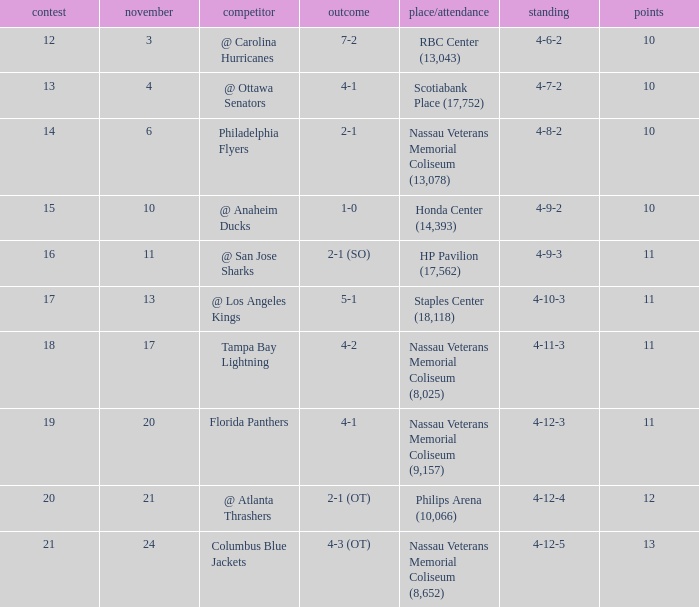What is the lowest entry point for a game where the score is 1-0? 15.0. 